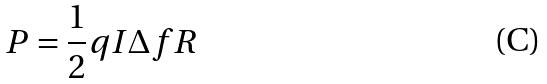Convert formula to latex. <formula><loc_0><loc_0><loc_500><loc_500>P = \frac { 1 } { 2 } q I \Delta f R</formula> 